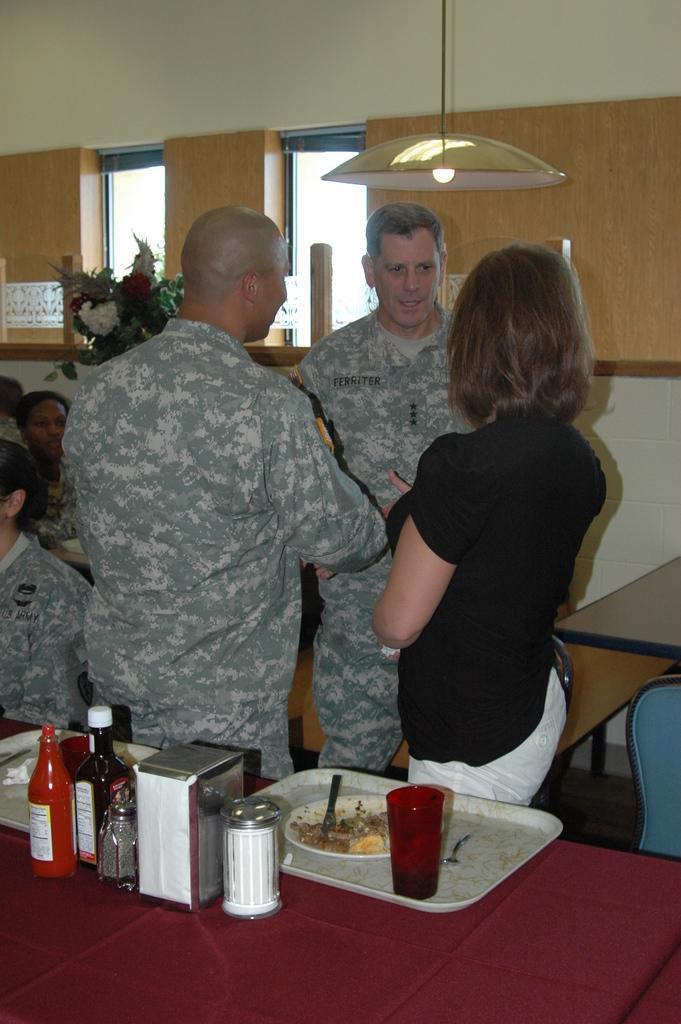How would you summarize this image in a sentence or two? In this picture we have two person standing and one woman they are talking with each other in front of them there is a table on the table we have bottles plate eatable things and back side some people are are sitting and they are some chairs. 